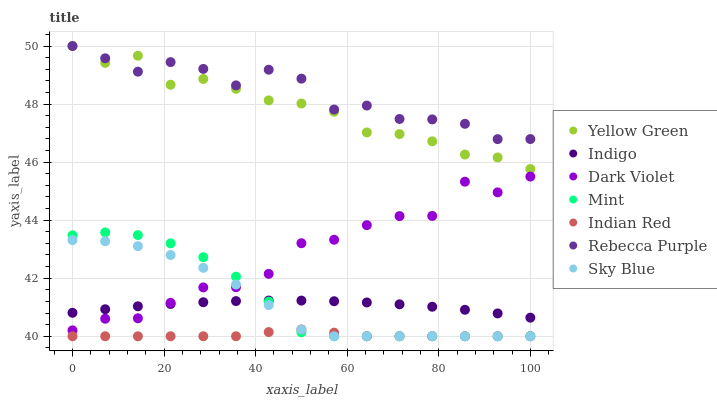Does Indian Red have the minimum area under the curve?
Answer yes or no. Yes. Does Rebecca Purple have the maximum area under the curve?
Answer yes or no. Yes. Does Yellow Green have the minimum area under the curve?
Answer yes or no. No. Does Yellow Green have the maximum area under the curve?
Answer yes or no. No. Is Indigo the smoothest?
Answer yes or no. Yes. Is Dark Violet the roughest?
Answer yes or no. Yes. Is Yellow Green the smoothest?
Answer yes or no. No. Is Yellow Green the roughest?
Answer yes or no. No. Does Indian Red have the lowest value?
Answer yes or no. Yes. Does Yellow Green have the lowest value?
Answer yes or no. No. Does Rebecca Purple have the highest value?
Answer yes or no. Yes. Does Dark Violet have the highest value?
Answer yes or no. No. Is Dark Violet less than Rebecca Purple?
Answer yes or no. Yes. Is Rebecca Purple greater than Sky Blue?
Answer yes or no. Yes. Does Mint intersect Indigo?
Answer yes or no. Yes. Is Mint less than Indigo?
Answer yes or no. No. Is Mint greater than Indigo?
Answer yes or no. No. Does Dark Violet intersect Rebecca Purple?
Answer yes or no. No. 